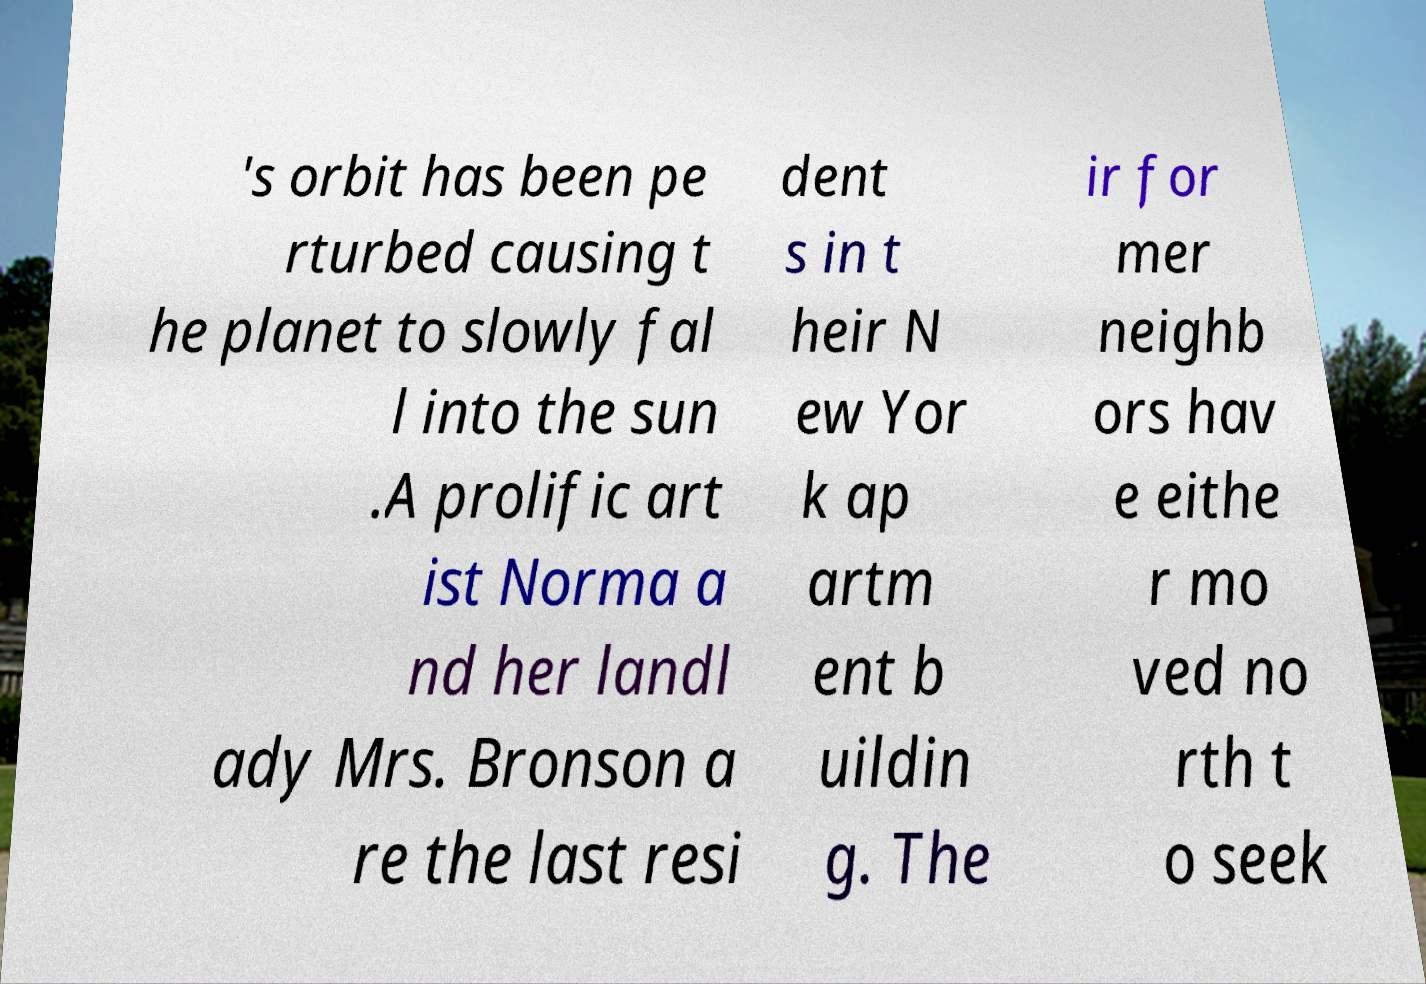Could you extract and type out the text from this image? 's orbit has been pe rturbed causing t he planet to slowly fal l into the sun .A prolific art ist Norma a nd her landl ady Mrs. Bronson a re the last resi dent s in t heir N ew Yor k ap artm ent b uildin g. The ir for mer neighb ors hav e eithe r mo ved no rth t o seek 